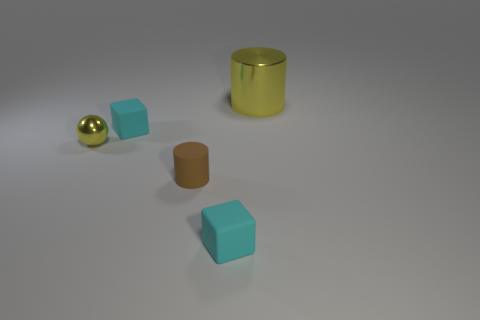How many yellow cubes are there?
Offer a terse response. 0. Is there a brown rubber object that has the same size as the rubber cylinder?
Your response must be concise. No. Are there fewer big objects that are in front of the big metallic cylinder than yellow shiny spheres?
Your answer should be compact. Yes. Do the matte cylinder and the yellow metallic cylinder have the same size?
Provide a succinct answer. No. The cylinder that is the same material as the small yellow thing is what size?
Keep it short and to the point. Large. How many tiny balls have the same color as the big cylinder?
Keep it short and to the point. 1. Is the number of cyan blocks behind the tiny brown cylinder less than the number of rubber cubes that are behind the large yellow metallic cylinder?
Your answer should be compact. No. There is a tiny thing that is behind the tiny shiny thing; is it the same shape as the brown thing?
Offer a terse response. No. Is there anything else that is made of the same material as the big cylinder?
Offer a terse response. Yes. Does the cyan cube that is behind the yellow sphere have the same material as the tiny yellow object?
Your answer should be compact. No. 